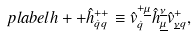<formula> <loc_0><loc_0><loc_500><loc_500>\ p l a b e l { h + + } \hat { h } ^ { + + } _ { \dot { q } q } \equiv \hat { v } ^ { + \underline { \mu } } _ { \dot { q } } \hat { h } _ { \underline { \mu } } ^ { \underline { \nu } } \hat { v } _ { \underline { \nu } q } ^ { + } ,</formula> 